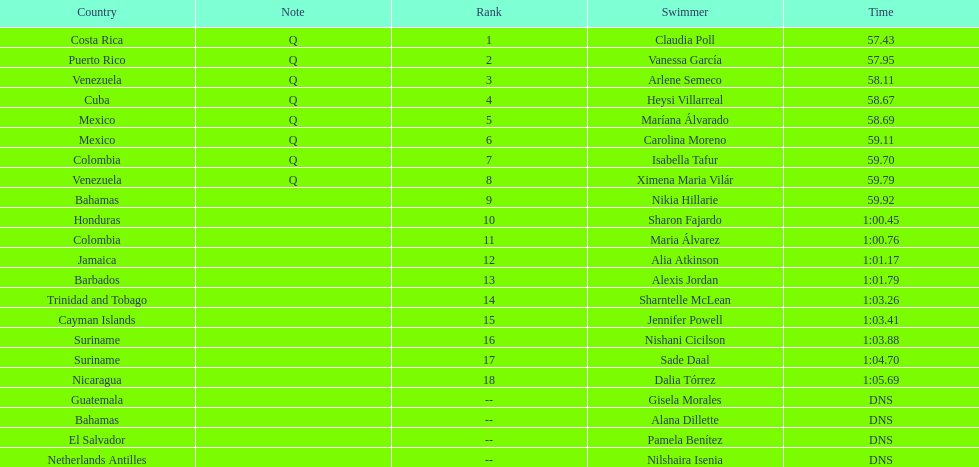Could you parse the entire table? {'header': ['Country', 'Note', 'Rank', 'Swimmer', 'Time'], 'rows': [['Costa Rica', 'Q', '1', 'Claudia Poll', '57.43'], ['Puerto Rico', 'Q', '2', 'Vanessa García', '57.95'], ['Venezuela', 'Q', '3', 'Arlene Semeco', '58.11'], ['Cuba', 'Q', '4', 'Heysi Villarreal', '58.67'], ['Mexico', 'Q', '5', 'Maríana Álvarado', '58.69'], ['Mexico', 'Q', '6', 'Carolina Moreno', '59.11'], ['Colombia', 'Q', '7', 'Isabella Tafur', '59.70'], ['Venezuela', 'Q', '8', 'Ximena Maria Vilár', '59.79'], ['Bahamas', '', '9', 'Nikia Hillarie', '59.92'], ['Honduras', '', '10', 'Sharon Fajardo', '1:00.45'], ['Colombia', '', '11', 'Maria Álvarez', '1:00.76'], ['Jamaica', '', '12', 'Alia Atkinson', '1:01.17'], ['Barbados', '', '13', 'Alexis Jordan', '1:01.79'], ['Trinidad and Tobago', '', '14', 'Sharntelle McLean', '1:03.26'], ['Cayman Islands', '', '15', 'Jennifer Powell', '1:03.41'], ['Suriname', '', '16', 'Nishani Cicilson', '1:03.88'], ['Suriname', '', '17', 'Sade Daal', '1:04.70'], ['Nicaragua', '', '18', 'Dalia Tórrez', '1:05.69'], ['Guatemala', '', '--', 'Gisela Morales', 'DNS'], ['Bahamas', '', '--', 'Alana Dillette', 'DNS'], ['El Salvador', '', '--', 'Pamela Benítez', 'DNS'], ['Netherlands Antilles', '', '--', 'Nilshaira Isenia', 'DNS']]} Who finished after claudia poll? Vanessa García. 